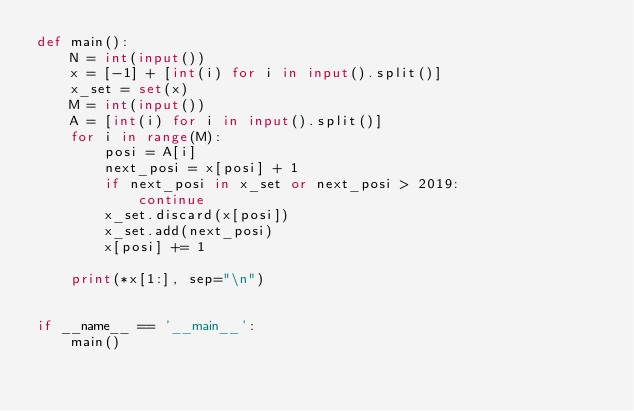<code> <loc_0><loc_0><loc_500><loc_500><_Python_>def main():
    N = int(input())
    x = [-1] + [int(i) for i in input().split()]
    x_set = set(x)
    M = int(input())
    A = [int(i) for i in input().split()]
    for i in range(M):
        posi = A[i]
        next_posi = x[posi] + 1
        if next_posi in x_set or next_posi > 2019:
            continue
        x_set.discard(x[posi])
        x_set.add(next_posi)
        x[posi] += 1

    print(*x[1:], sep="\n")


if __name__ == '__main__':
    main()

</code> 